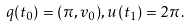Convert formula to latex. <formula><loc_0><loc_0><loc_500><loc_500>q ( t _ { 0 } ) = ( \pi , v _ { 0 } ) , u ( t _ { 1 } ) = 2 \pi .</formula> 